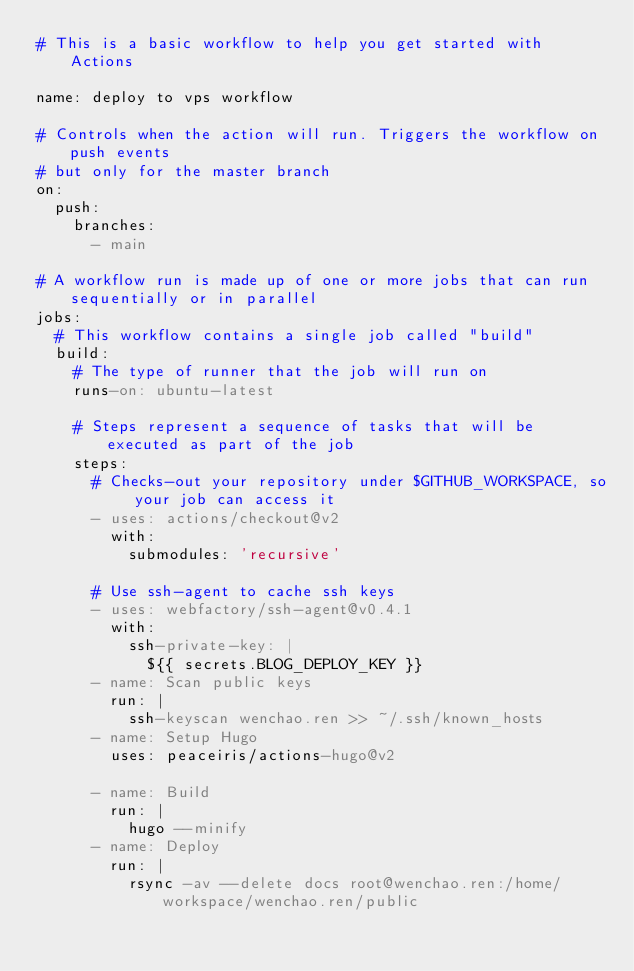<code> <loc_0><loc_0><loc_500><loc_500><_YAML_># This is a basic workflow to help you get started with Actions

name: deploy to vps workflow

# Controls when the action will run. Triggers the workflow on push events
# but only for the master branch
on:
  push:
    branches:
      - main

# A workflow run is made up of one or more jobs that can run sequentially or in parallel
jobs:
  # This workflow contains a single job called "build"
  build:
    # The type of runner that the job will run on
    runs-on: ubuntu-latest

    # Steps represent a sequence of tasks that will be executed as part of the job
    steps:
      # Checks-out your repository under $GITHUB_WORKSPACE, so your job can access it
      - uses: actions/checkout@v2
        with:
          submodules: 'recursive'

      # Use ssh-agent to cache ssh keys
      - uses: webfactory/ssh-agent@v0.4.1
        with:
          ssh-private-key: |
            ${{ secrets.BLOG_DEPLOY_KEY }}
      - name: Scan public keys
        run: |
          ssh-keyscan wenchao.ren >> ~/.ssh/known_hosts
      - name: Setup Hugo
        uses: peaceiris/actions-hugo@v2

      - name: Build
        run: |
          hugo --minify
      - name: Deploy
        run: |
          rsync -av --delete docs root@wenchao.ren:/home/workspace/wenchao.ren/public</code> 